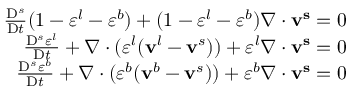<formula> <loc_0><loc_0><loc_500><loc_500>\begin{array} { r } { \frac { D ^ { s } } { D t } ( 1 - \varepsilon ^ { l } - \varepsilon ^ { b } ) + ( 1 - \varepsilon ^ { l } - \varepsilon ^ { b } ) \nabla \cdot v ^ { s } = 0 } \\ { \frac { D ^ { s } \varepsilon ^ { l } } { D t } + \nabla \cdot ( \varepsilon ^ { l } ( v ^ { l } - v ^ { s } ) ) + \varepsilon ^ { l } \nabla \cdot v ^ { s } = 0 } \\ { \frac { D ^ { s } \varepsilon ^ { b } } { D t } + \nabla \cdot ( \varepsilon ^ { b } ( v ^ { b } - v ^ { s } ) ) + \varepsilon ^ { b } \nabla \cdot v ^ { s } = 0 } \end{array}</formula> 